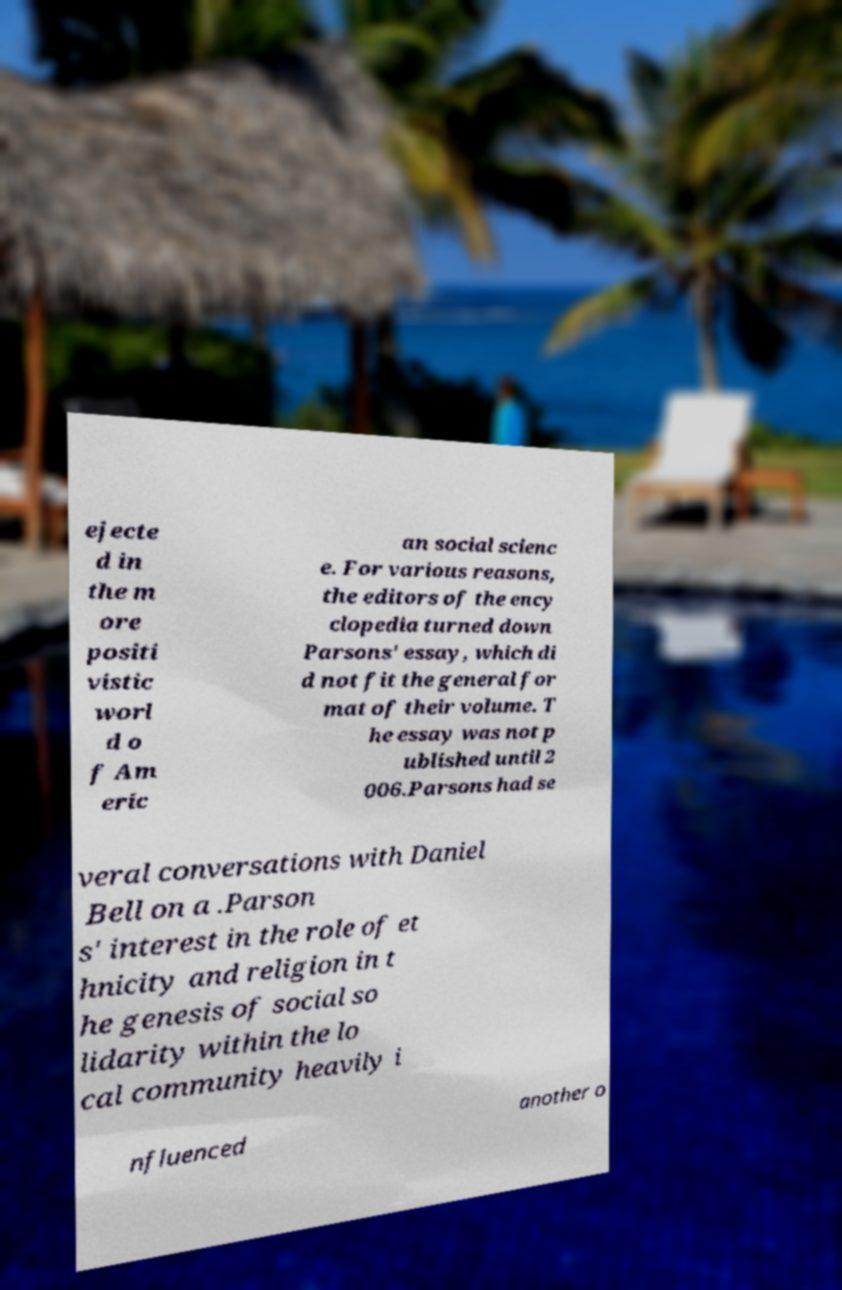Can you accurately transcribe the text from the provided image for me? ejecte d in the m ore positi vistic worl d o f Am eric an social scienc e. For various reasons, the editors of the ency clopedia turned down Parsons' essay, which di d not fit the general for mat of their volume. T he essay was not p ublished until 2 006.Parsons had se veral conversations with Daniel Bell on a .Parson s' interest in the role of et hnicity and religion in t he genesis of social so lidarity within the lo cal community heavily i nfluenced another o 